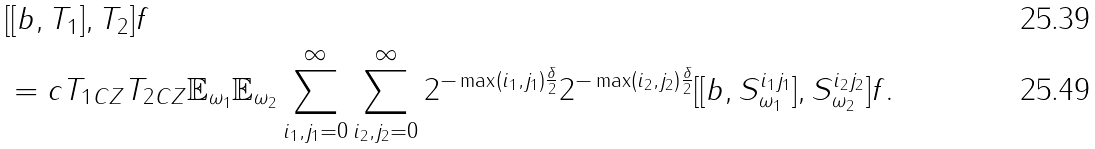Convert formula to latex. <formula><loc_0><loc_0><loc_500><loc_500>& [ [ b , T _ { 1 } ] , T _ { 2 } ] f \\ & = c \| T _ { 1 } \| _ { C Z } \| T _ { 2 } \| _ { C Z } \mathbb { E } _ { \omega _ { 1 } } \mathbb { E } _ { \omega _ { 2 } } \sum _ { i _ { 1 } , j _ { 1 } = 0 } ^ { \infty } \sum _ { i _ { 2 } , j _ { 2 } = 0 } ^ { \infty } 2 ^ { - \max ( i _ { 1 } , j _ { 1 } ) \frac { \delta } { 2 } } 2 ^ { - \max ( i _ { 2 } , j _ { 2 } ) \frac { \delta } { 2 } } [ [ b , S ^ { i _ { 1 } j _ { 1 } } _ { \omega _ { 1 } } ] , S ^ { i _ { 2 } j _ { 2 } } _ { \omega _ { 2 } } ] f .</formula> 